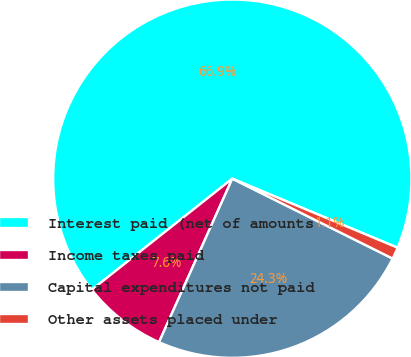<chart> <loc_0><loc_0><loc_500><loc_500><pie_chart><fcel>Interest paid (net of amounts<fcel>Income taxes paid<fcel>Capital expenditures not paid<fcel>Other assets placed under<nl><fcel>66.95%<fcel>7.65%<fcel>24.35%<fcel>1.06%<nl></chart> 